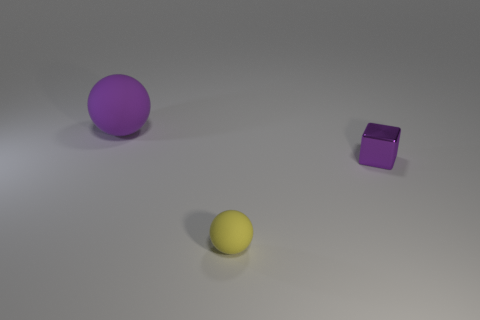What could the colors in this image represent? The colors chosen for the objects in this image—vibrant yellow and varying shades of purple—may carry symbolism. Yellow often conveys energy, optimism, and happiness, whereas purple can signify creativity, royalty, or mystery. The choice of these colors against the neutral background may be intended to evoke a balance of warmth (yellow) and nobility or introspection (purple).  Is there any indication of how these objects might be used or what they represent? Without any explicit context, we can only speculate on their possible uses or symbolic meanings. Given their shapes and textures, the spherical objects might represent playfulness or wholesomeness as balls are commonly associated with games and sports. The cube might suggest structure or order due to its geometric form. In a symbolic sense, these objects could represent basic geometric shapes used as the building blocks of more complex ideas or realities. 